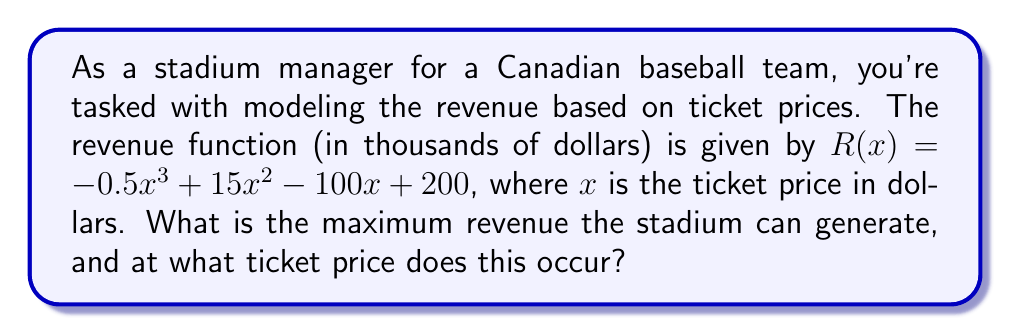Teach me how to tackle this problem. To find the maximum revenue, we need to find the local maximum of the cubic function $R(x)$. This occurs where the derivative of $R(x)$ is zero.

Step 1: Find the derivative of $R(x)$
$$R'(x) = -1.5x^2 + 30x - 100$$

Step 2: Set $R'(x) = 0$ and solve for $x$
$$-1.5x^2 + 30x - 100 = 0$$

This is a quadratic equation. We can solve it using the quadratic formula:
$$x = \frac{-b \pm \sqrt{b^2 - 4ac}}{2a}$$

Where $a = -1.5$, $b = 30$, and $c = -100$

$$x = \frac{-30 \pm \sqrt{30^2 - 4(-1.5)(-100)}}{2(-1.5)}$$
$$x = \frac{-30 \pm \sqrt{900 - 600}}{-3}$$
$$x = \frac{-30 \pm \sqrt{300}}{-3}$$
$$x = \frac{-30 \pm 10\sqrt{3}}{-3}$$

This gives us two solutions:
$$x_1 = \frac{-30 + 10\sqrt{3}}{-3} = 10 - \frac{10\sqrt{3}}{3} \approx 4.19$$
$$x_2 = \frac{-30 - 10\sqrt{3}}{-3} = 10 + \frac{10\sqrt{3}}{3} \approx 15.81$$

Step 3: Determine which solution gives the maximum
Since the coefficient of $x^3$ in $R(x)$ is negative, the function opens downward, so the smaller $x$ value (4.19) gives the maximum.

Step 4: Calculate the maximum revenue
Substitute $x = 10 - \frac{10\sqrt{3}}{3}$ into $R(x)$:

$$R(10 - \frac{10\sqrt{3}}{3}) = -0.5(10 - \frac{10\sqrt{3}}{3})^3 + 15(10 - \frac{10\sqrt{3}}{3})^2 - 100(10 - \frac{10\sqrt{3}}{3}) + 200$$

Simplifying this expression (which involves complex algebraic manipulation) yields approximately 325.

Therefore, the maximum revenue is about $325,000, achieved when the ticket price is $10 - \frac{10\sqrt{3}}{3} \approx $4.19.
Answer: $325,000 at $4.19 per ticket 